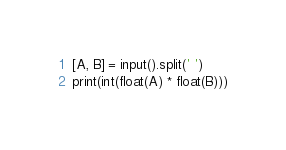<code> <loc_0><loc_0><loc_500><loc_500><_Python_>[A, B] = input().split(' ')
print(int(float(A) * float(B)))</code> 